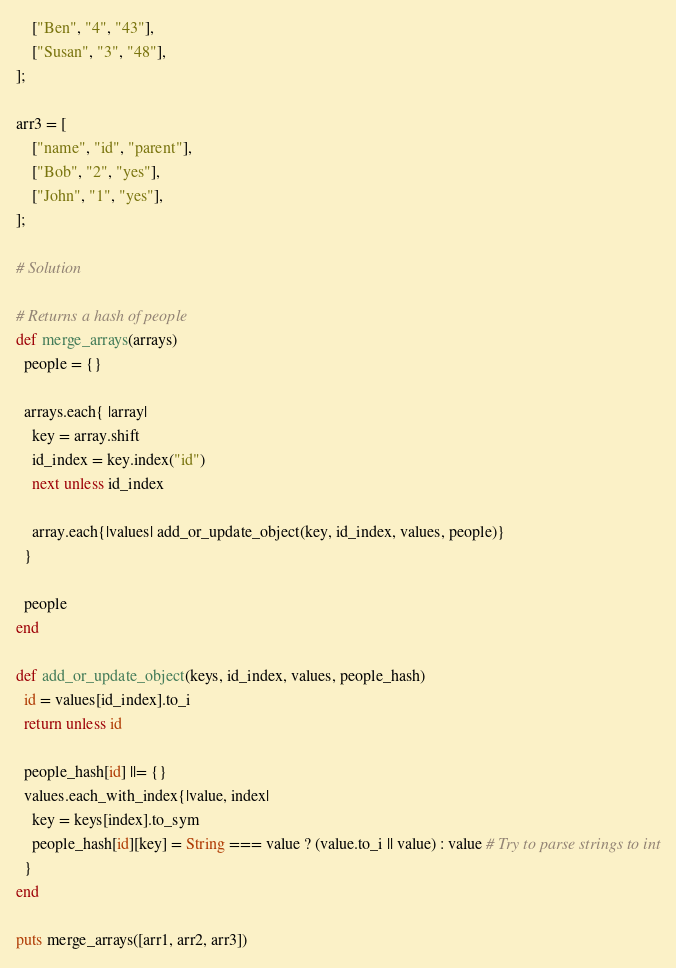Convert code to text. <code><loc_0><loc_0><loc_500><loc_500><_Ruby_>    ["Ben", "4", "43"],
    ["Susan", "3", "48"],
];

arr3 = [
    ["name", "id", "parent"],
    ["Bob", "2", "yes"],
    ["John", "1", "yes"],
];

# Solution

# Returns a hash of people
def merge_arrays(arrays)
  people = {}

  arrays.each{ |array|
    key = array.shift
    id_index = key.index("id")
    next unless id_index

    array.each{|values| add_or_update_object(key, id_index, values, people)}
  }

  people
end

def add_or_update_object(keys, id_index, values, people_hash)
  id = values[id_index].to_i
  return unless id

  people_hash[id] ||= {}
  values.each_with_index{|value, index|
    key = keys[index].to_sym
    people_hash[id][key] = String === value ? (value.to_i || value) : value # Try to parse strings to int
  }
end

puts merge_arrays([arr1, arr2, arr3])
</code> 